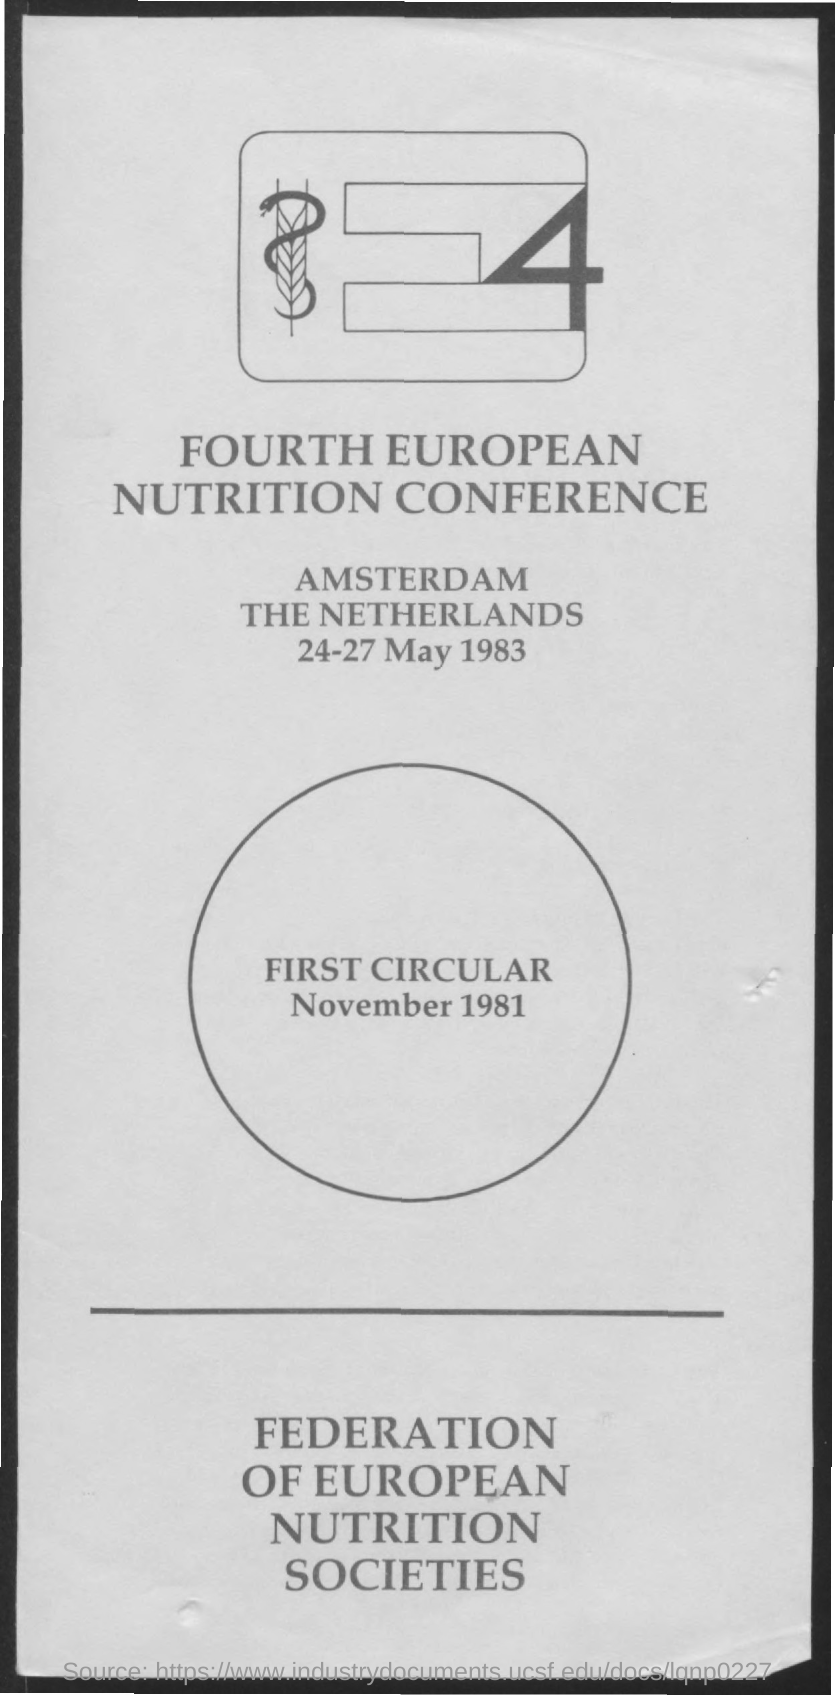When is the Fourth European Nutrition Conference held?
Your answer should be compact. 24-27 May 1983. 